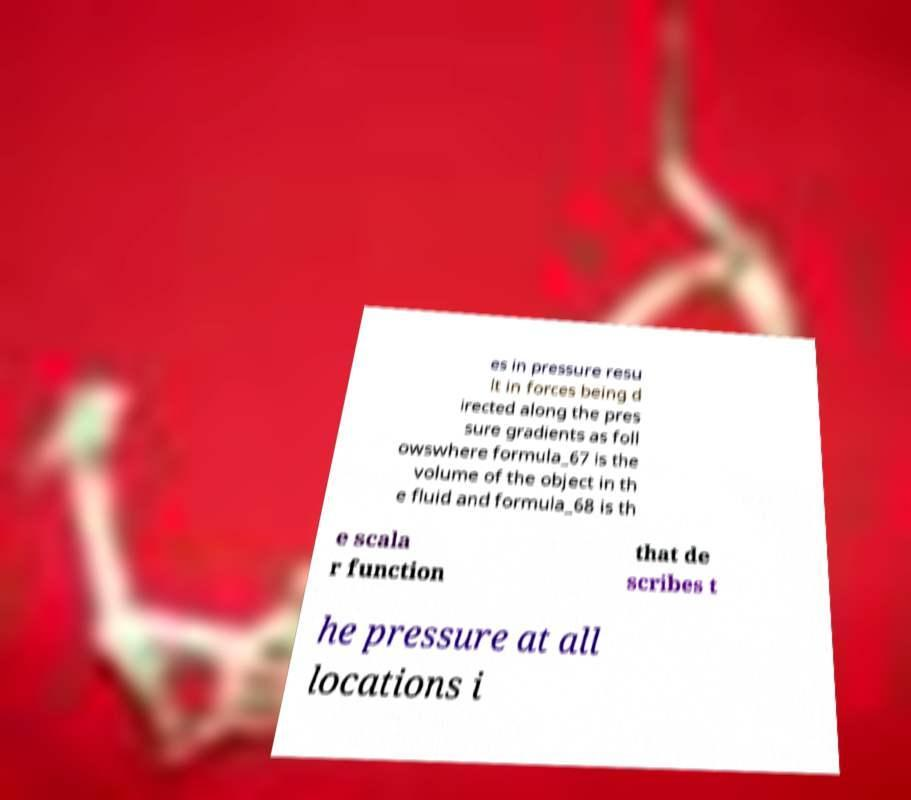Could you extract and type out the text from this image? es in pressure resu lt in forces being d irected along the pres sure gradients as foll owswhere formula_67 is the volume of the object in th e fluid and formula_68 is th e scala r function that de scribes t he pressure at all locations i 